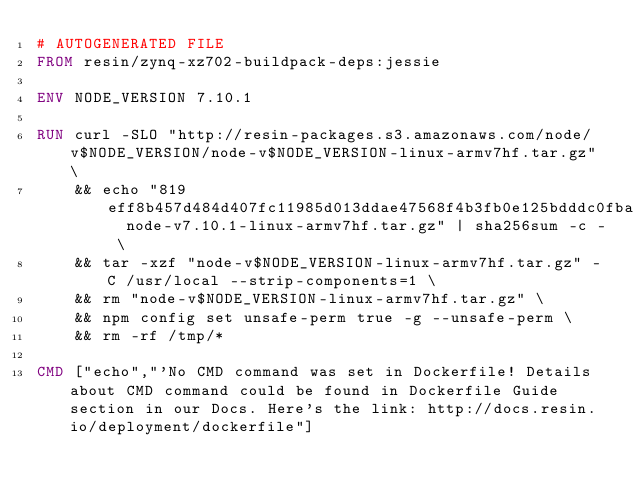Convert code to text. <code><loc_0><loc_0><loc_500><loc_500><_Dockerfile_># AUTOGENERATED FILE
FROM resin/zynq-xz702-buildpack-deps:jessie

ENV NODE_VERSION 7.10.1

RUN curl -SLO "http://resin-packages.s3.amazonaws.com/node/v$NODE_VERSION/node-v$NODE_VERSION-linux-armv7hf.tar.gz" \
	&& echo "819eff8b457d484d407fc11985d013ddae47568f4b3fb0e125bdddc0fba32875  node-v7.10.1-linux-armv7hf.tar.gz" | sha256sum -c - \
	&& tar -xzf "node-v$NODE_VERSION-linux-armv7hf.tar.gz" -C /usr/local --strip-components=1 \
	&& rm "node-v$NODE_VERSION-linux-armv7hf.tar.gz" \
	&& npm config set unsafe-perm true -g --unsafe-perm \
	&& rm -rf /tmp/*

CMD ["echo","'No CMD command was set in Dockerfile! Details about CMD command could be found in Dockerfile Guide section in our Docs. Here's the link: http://docs.resin.io/deployment/dockerfile"]
</code> 